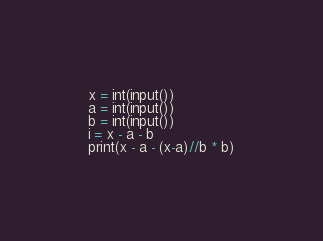Convert code to text. <code><loc_0><loc_0><loc_500><loc_500><_Python_>x = int(input())
a = int(input())
b = int(input())
i = x - a - b
print(x - a - (x-a)//b * b)
</code> 